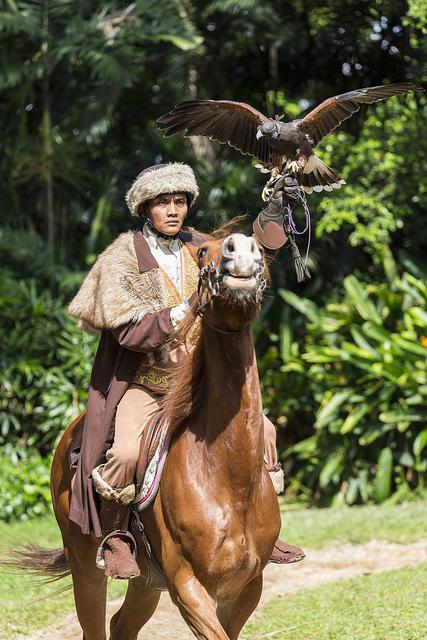Could this man be a mongol?
Concise answer only. Yes. Is the bird flying?
Keep it brief. No. What country in the men's clothing associated with?
Write a very short answer. Mongolia. 